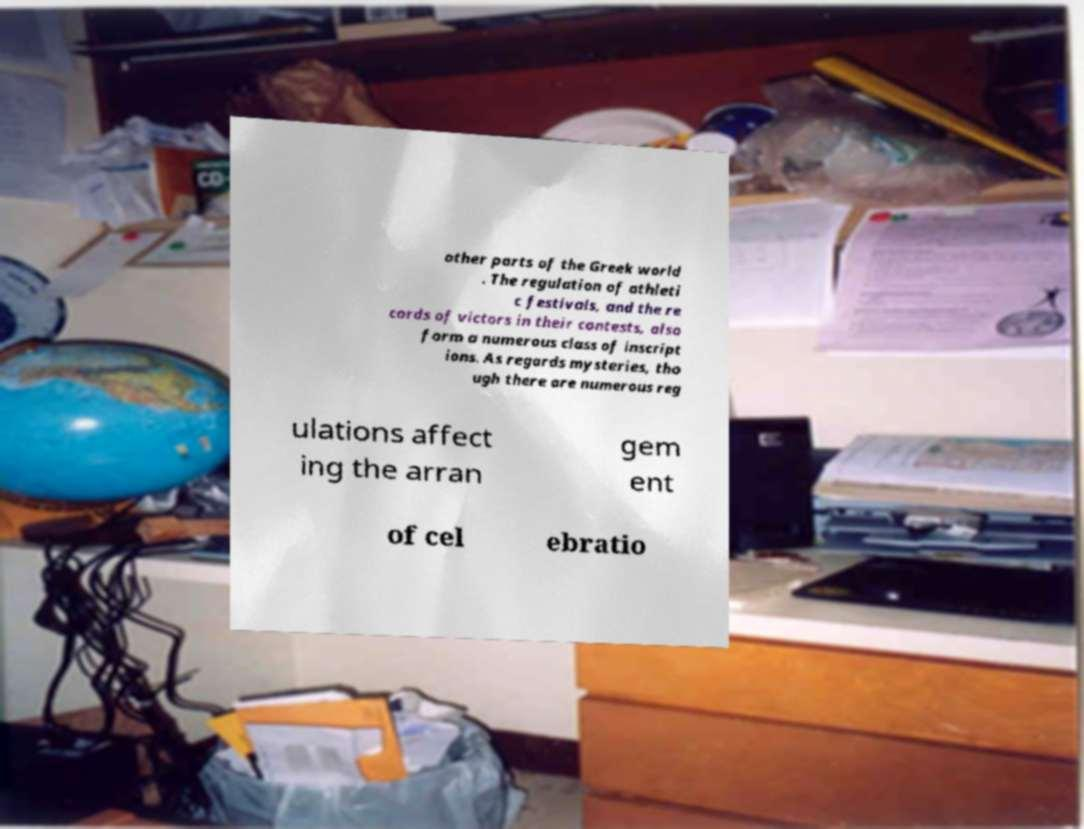For documentation purposes, I need the text within this image transcribed. Could you provide that? other parts of the Greek world . The regulation of athleti c festivals, and the re cords of victors in their contests, also form a numerous class of inscript ions. As regards mysteries, tho ugh there are numerous reg ulations affect ing the arran gem ent of cel ebratio 